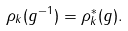Convert formula to latex. <formula><loc_0><loc_0><loc_500><loc_500>\rho _ { k } ( g ^ { - 1 } ) = \rho _ { k } ^ { * } ( g ) .</formula> 